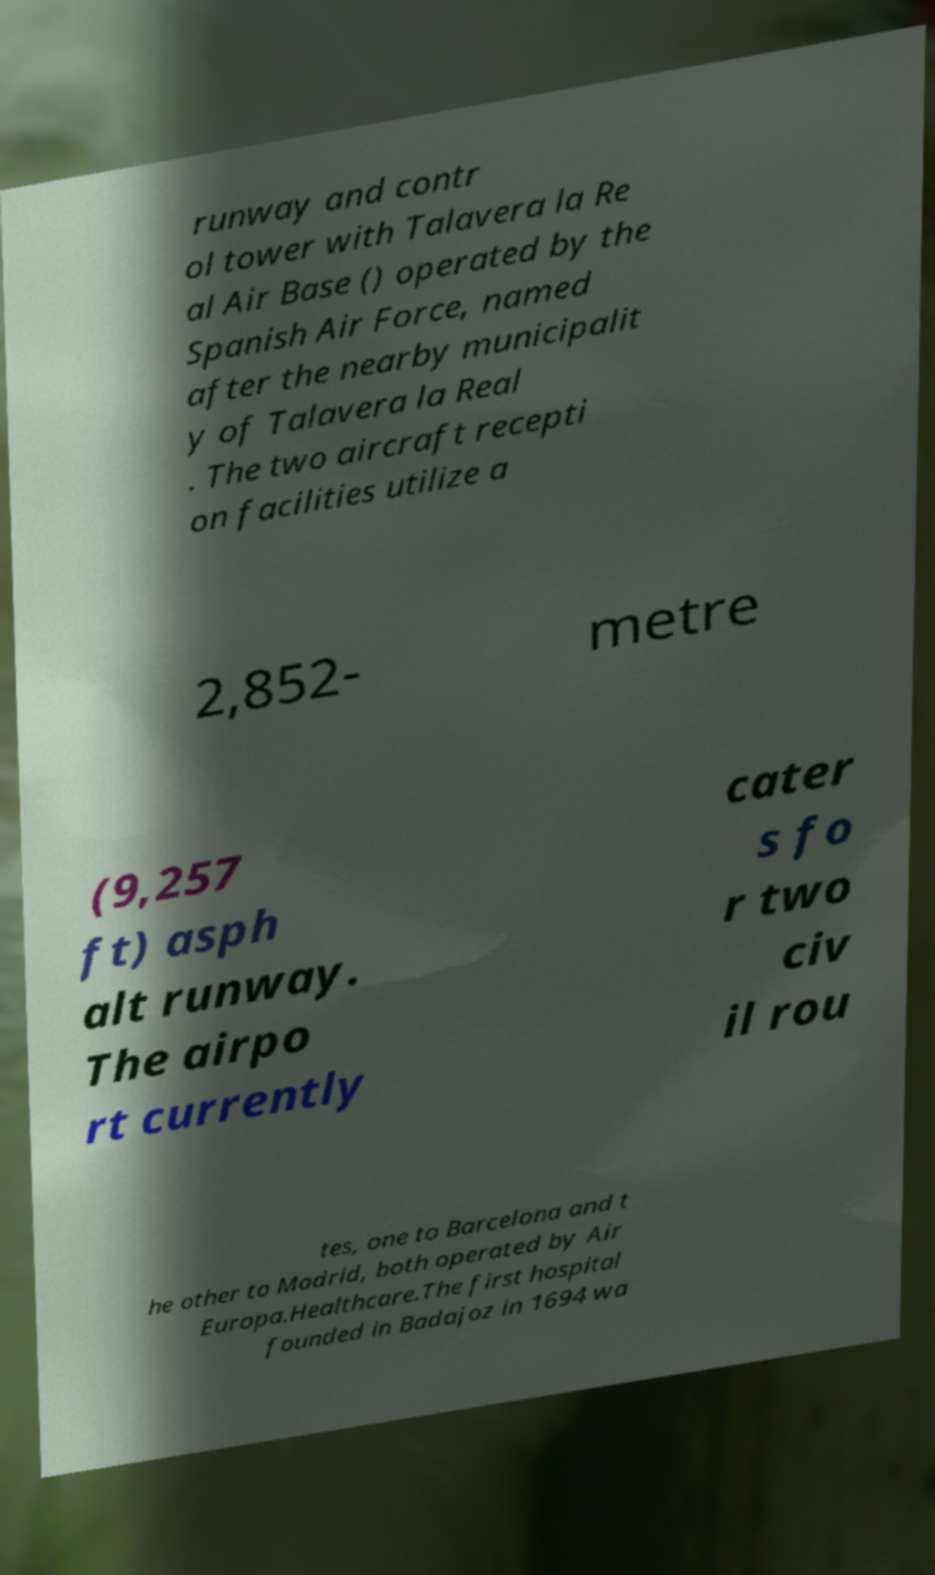Please identify and transcribe the text found in this image. runway and contr ol tower with Talavera la Re al Air Base () operated by the Spanish Air Force, named after the nearby municipalit y of Talavera la Real . The two aircraft recepti on facilities utilize a 2,852- metre (9,257 ft) asph alt runway. The airpo rt currently cater s fo r two civ il rou tes, one to Barcelona and t he other to Madrid, both operated by Air Europa.Healthcare.The first hospital founded in Badajoz in 1694 wa 